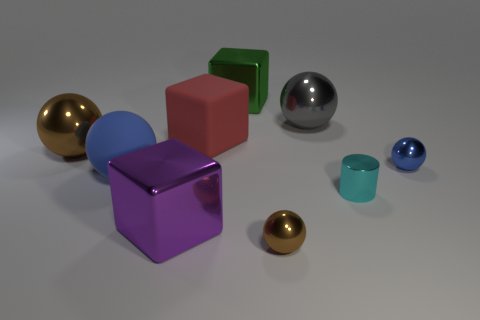What is the size relationship between the objects on the table? The objects vary in size quite significantly. The largest appears to be the purple cube, followed by the pink cube and the large ball, while the small spheres, including the gold and blue ones, are the smallest. The smallest cube is the green one, which is intermediate between the larger cubes and the small spheres. 